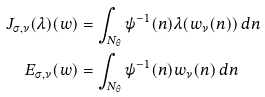Convert formula to latex. <formula><loc_0><loc_0><loc_500><loc_500>J _ { \sigma , \nu } ( \lambda ) ( w ) & = \int _ { { N } _ { \theta } } \psi ^ { - 1 } ( n ) \lambda ( w _ { \nu } ( n ) ) \, d n \\ E _ { \sigma , \nu } ( w ) & = \int _ { { N } _ { \theta } } \psi ^ { - 1 } ( n ) w _ { \nu } ( n ) \, d n</formula> 